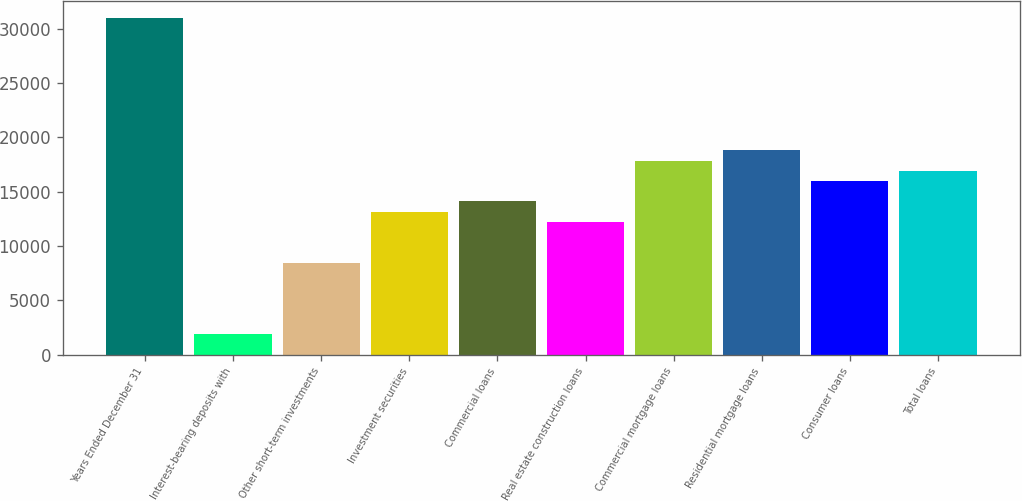<chart> <loc_0><loc_0><loc_500><loc_500><bar_chart><fcel>Years Ended December 31<fcel>Interest-bearing deposits with<fcel>Other short-term investments<fcel>Investment securities<fcel>Commercial loans<fcel>Real estate construction loans<fcel>Commercial mortgage loans<fcel>Residential mortgage loans<fcel>Consumer loans<fcel>Total loans<nl><fcel>31026.6<fcel>1880.43<fcel>8461.83<fcel>13162.8<fcel>14103<fcel>12222.6<fcel>17863.8<fcel>18804<fcel>15983.4<fcel>16923.6<nl></chart> 